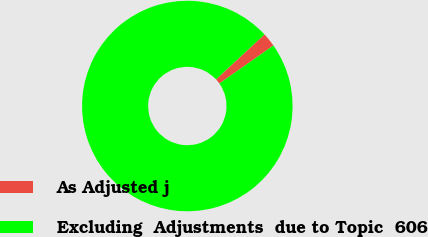Convert chart. <chart><loc_0><loc_0><loc_500><loc_500><pie_chart><fcel>As Adjusted j<fcel>Excluding  Adjustments  due to Topic  606<nl><fcel>2.16%<fcel>97.84%<nl></chart> 